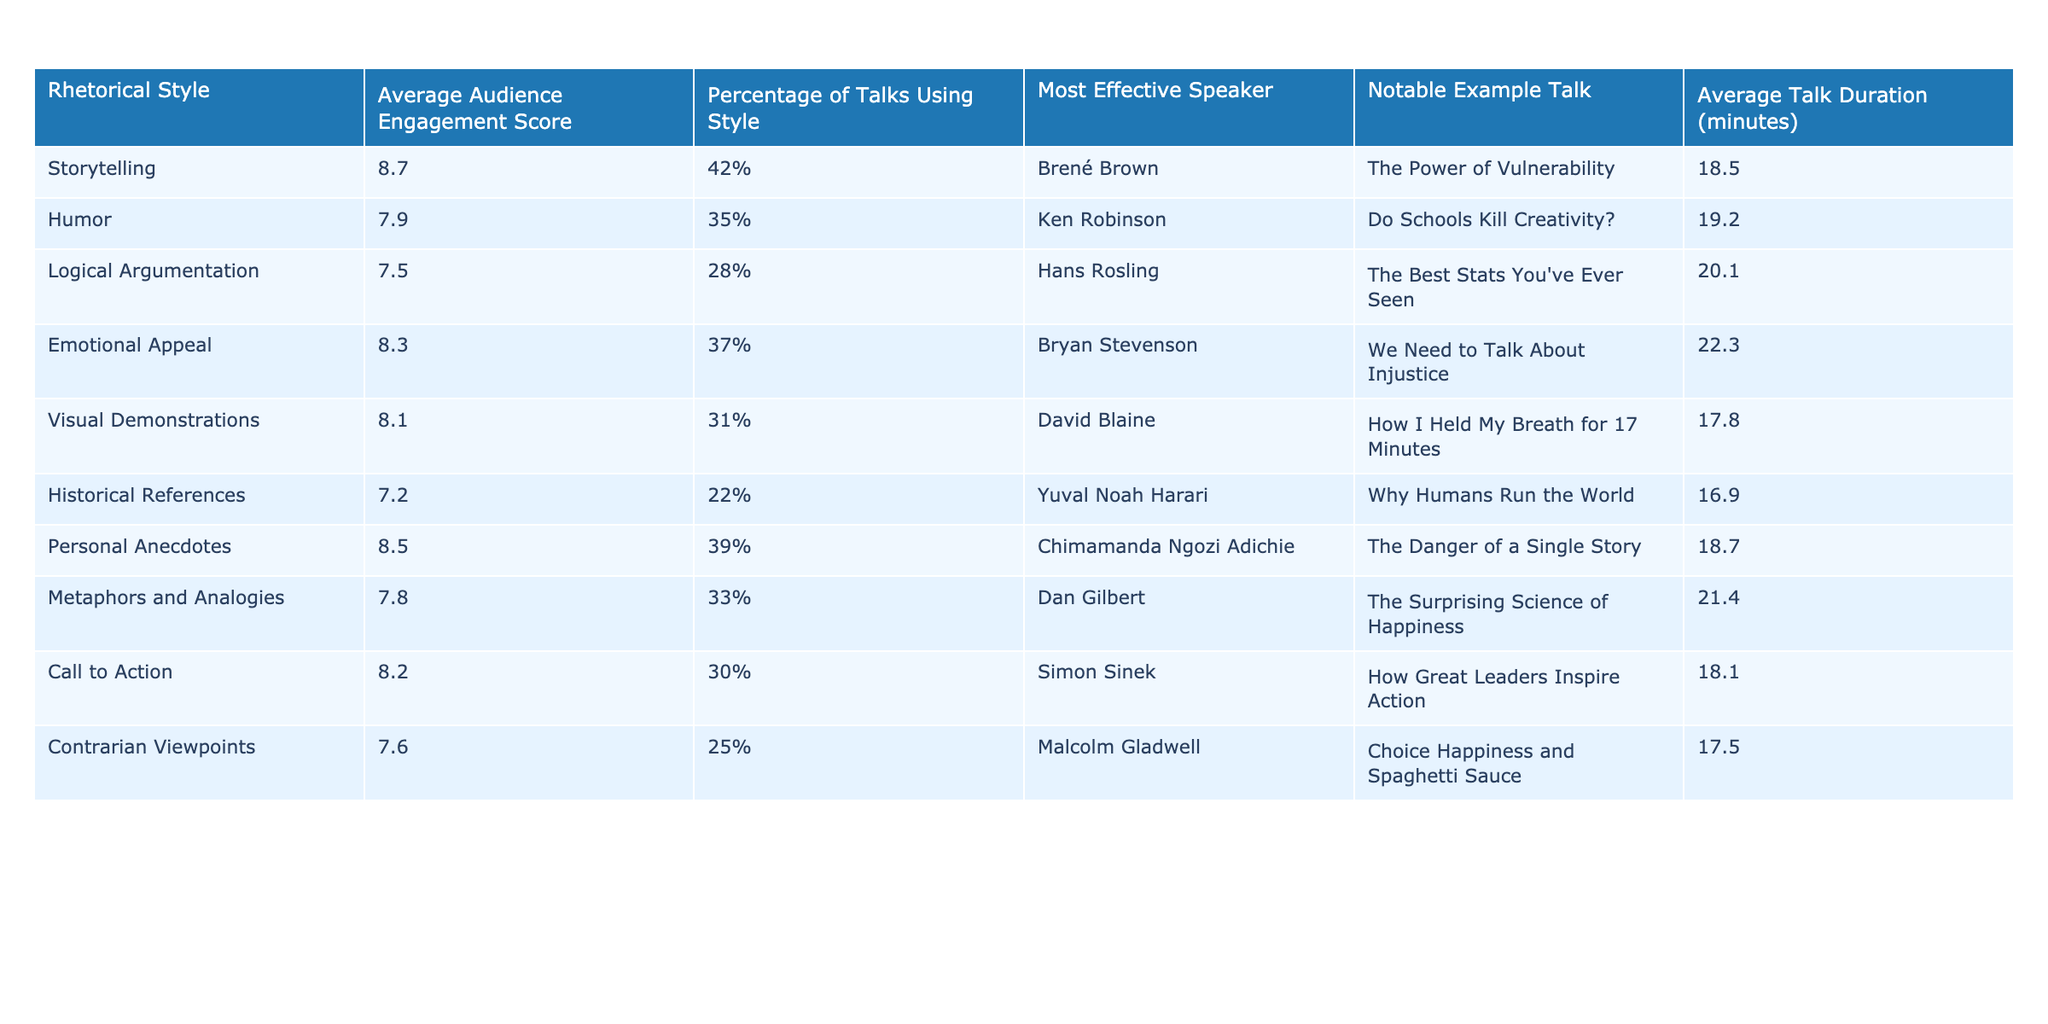What is the average audience engagement score for storytelling? The average audience engagement score for storytelling is listed in the table under the "Average Audience Engagement Score" column, which shows a value of 8.7.
Answer: 8.7 Which rhetorical style is used in the most percentage of talks? The percentage of talks using each rhetorical style can be found in the "Percentage of Talks Using Style" column. Storytelling has the highest percentage at 42%.
Answer: Storytelling Who is the most effective speaker according to the table for emotional appeal? The "Most Effective Speaker" column indicates that Bryan Stevenson is the most effective speaker for emotional appeal, as listed in the respective row.
Answer: Bryan Stevenson What is the average talk duration of the talk with the highest audience engagement score? The "Average Audience Engagement Score" shows that storytelling has the highest score of 8.7, and referring to the same row, the "Average Talk Duration" is 18.5 minutes.
Answer: 18.5 minutes How many styles have an average audience engagement score of 8 or higher? By scanning the "Average Audience Engagement Score" column, we can count storytelling (8.7), emotional appeal (8.3), personal anecdotes (8.5), and humor (7.9), which gives us 4 styles above 8. However, only storytelling, emotional appeal, and personal anecdotes actually score 8 or more. Thus, there are 3 styles.
Answer: 3 What is the difference in average audience engagement scores between humor and contrarian viewpoints? First, find the average scores for both rhetorical styles: humor has 7.9 and contrarian viewpoints have 7.6. Then subtract 7.6 from 7.9, giving a difference of 0.3.
Answer: 0.3 Is there a rhetorical style that has both the lowest average audience engagement score and the least percentage of talks using it? Checking both the "Average Audience Engagement Score" and "Percentage of Talks Using Style," historical references has the lowest score (7.2) and also the lowest percentage (22%). Thus, the answer is yes.
Answer: Yes Which rhetorical style has the greatest difference between average audience engagement score and percentage of talks using it? Calculate the difference for each style by subtracting the "Percentage of Talks Using Style" (converted to a numerical scale) from the "Average Audience Engagement Score." The style with the greatest difference is storytelling, where the engagement score is 8.7 with 42%, giving a difference of 8.7 - 0.42 = 8.28.
Answer: Storytelling What are the average audience engagement scores for the styles that use humor and historical references? The scores for humor (7.9) and historical references (7.2) can be found in their respective rows. Add these two scores together: 7.9 + 7.2 = 15.1, and then divide by 2 for the average score of these two styles: 15.1 / 2 = 7.55.
Answer: 7.55 Which rhetorical style is associated with Simon Sinek and what is its average engagement score? Simon Sinek is associated with the "Call to Action" style, as noted in the table. Looking at the "Average Audience Engagement Score" for that style, it is 8.2.
Answer: 8.2 